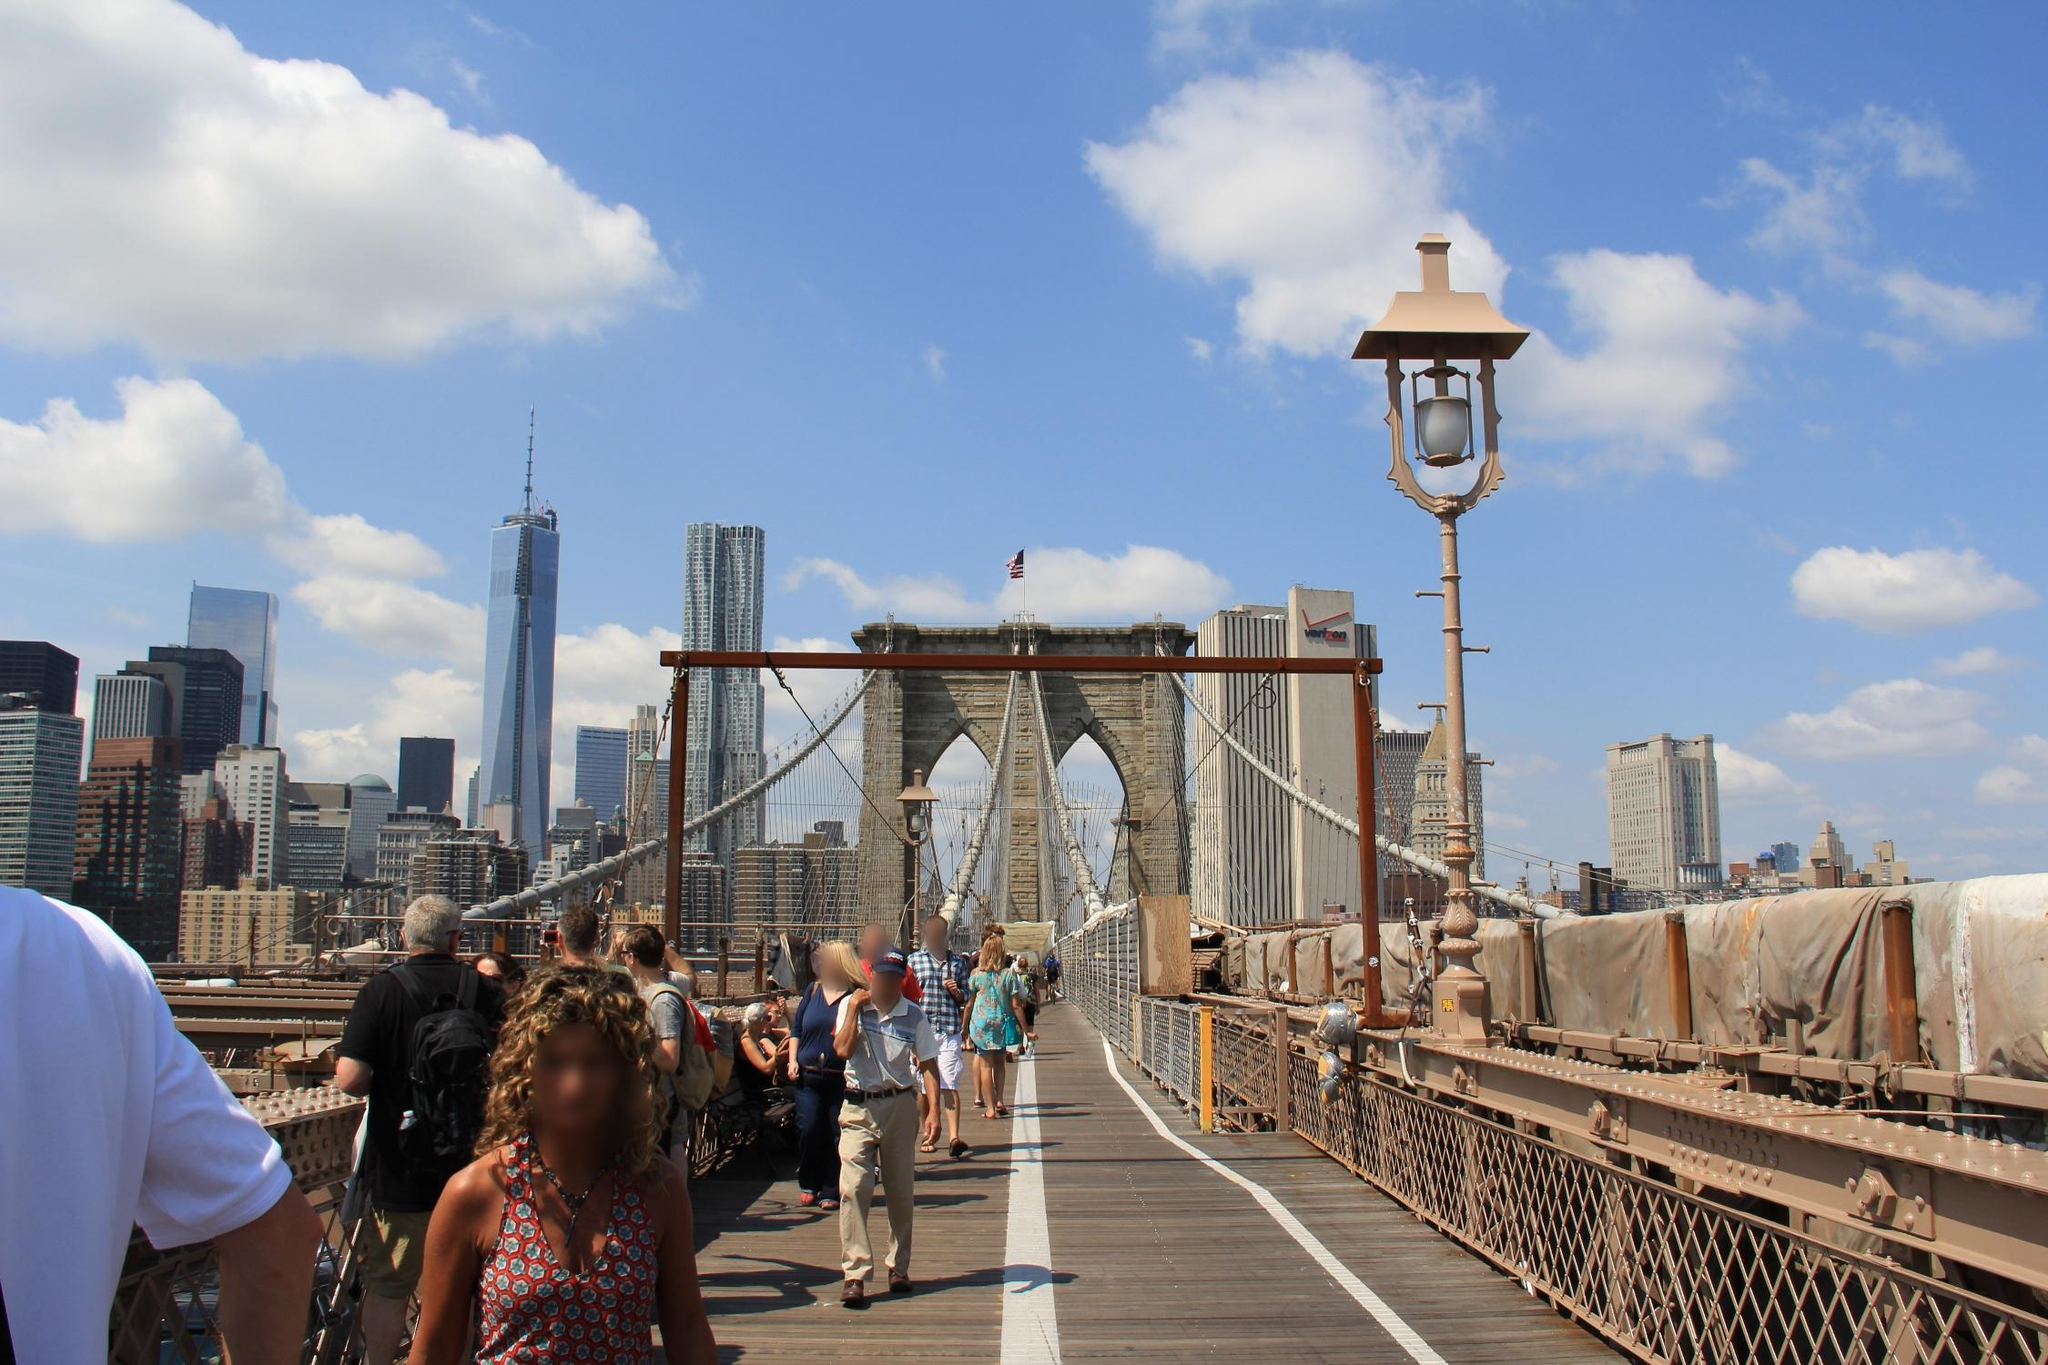If this was the setting for a romantic film, describe a scene. In the golden glow of a late afternoon, the Brooklyn Bridge becomes the setting for a poignant romantic film scene. The camera captures the silhouettes of two lovers, hand in hand, walking leisurely along the wooden walkway. The gentle breeze plays with the woman’s hair as they pause halfway, under the majestic arches. They share a quiet, heartfelt conversation, the bustling city around them a mere backdrop to their world. The man pulls out a vintage camera, insisting on capturing the moment forever; as the shutter clicks, they laugh, a sound of pure joy that echoes off the steel cables. As they lean in for a kiss, the sun dips lower, casting a warm amber hue on their faces and the skyline behind them. Above, the American flag waves gently in the breeze, symbolizing dreams and hopes as the scene fades into a sunset drenched in hues of love and promise. Describe another realistic scenario happening on the bridge. A group of friends, clearly tourists, are seen excitedly pointing and discussing the various landmarks they can spot from the bridge. One of them holds up a map, trying to get their bearings, while another snaps photos with a high-end camera. They take turns posing against the backdrop of the Manhattan skyline, each trying to get the perfect shot for their travel album. The energy among them is infectious, their excitement palpable as they bask in the vibrant atmosphere of this iconic spot. 